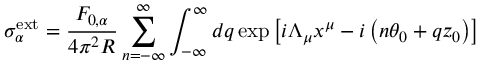Convert formula to latex. <formula><loc_0><loc_0><loc_500><loc_500>\sigma _ { \alpha } ^ { e x t } = \frac { F _ { 0 , \alpha } } { 4 \pi ^ { 2 } R } \sum _ { n = - \infty } ^ { \infty } \int _ { - \infty } ^ { \infty } d q \exp \left [ i \Lambda _ { \mu } x ^ { \mu } - i \left ( n \theta _ { 0 } + q z _ { 0 } \right ) \right ]</formula> 